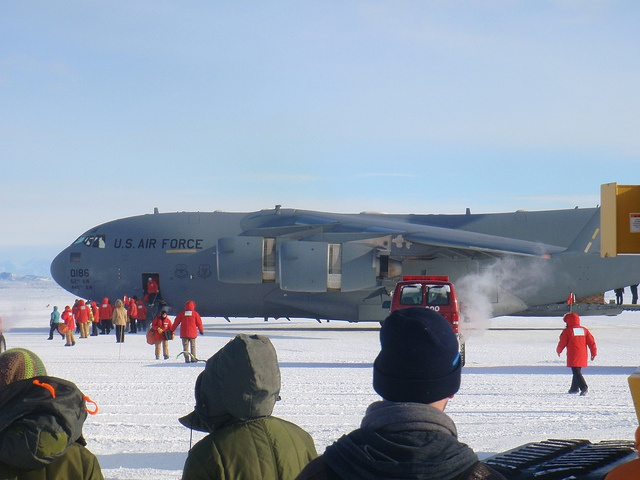Describe the objects in this image and their specific colors. I can see airplane in lightblue, gray, darkblue, and darkgray tones, people in lightblue, black, gray, and darkblue tones, people in lightblue, black, gray, and darkgreen tones, people in lightblue, black, olive, and gray tones, and backpack in lightblue, black, gray, and maroon tones in this image. 